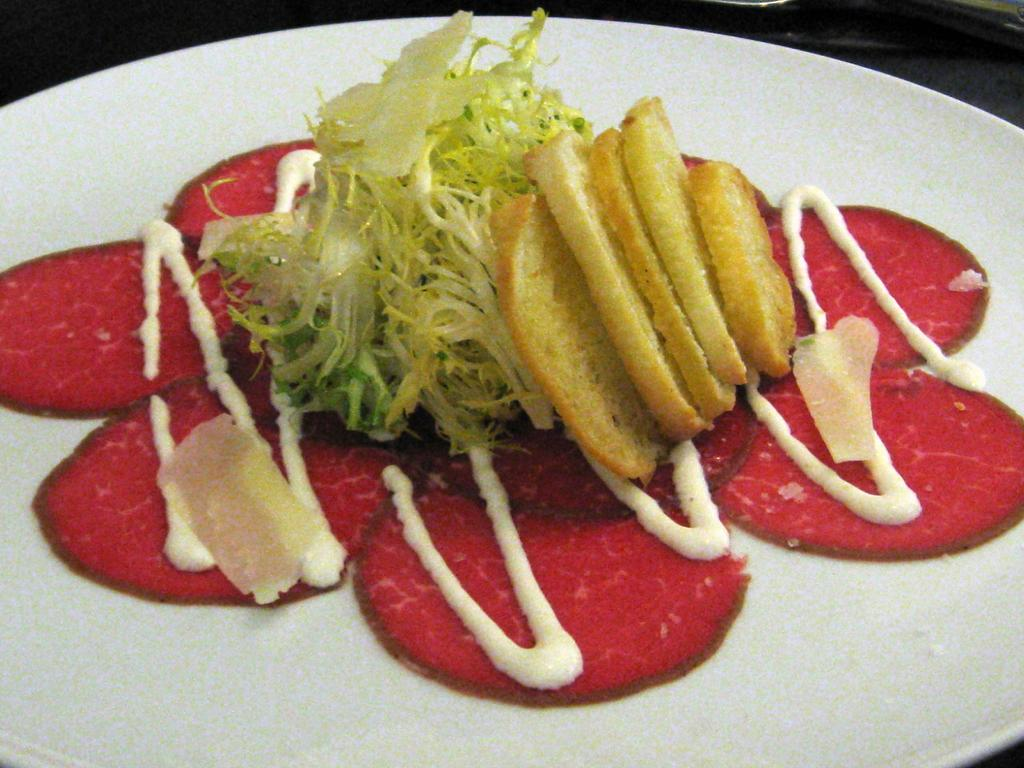What is the main subject of the image? There is a food item in the image. How is the food item presented in the image? The food item is placed on a plate. What type of throne can be seen in the image? There is no throne present in the image. Is there a fireman attending to the food item in the image? There is no fireman present in the image. 